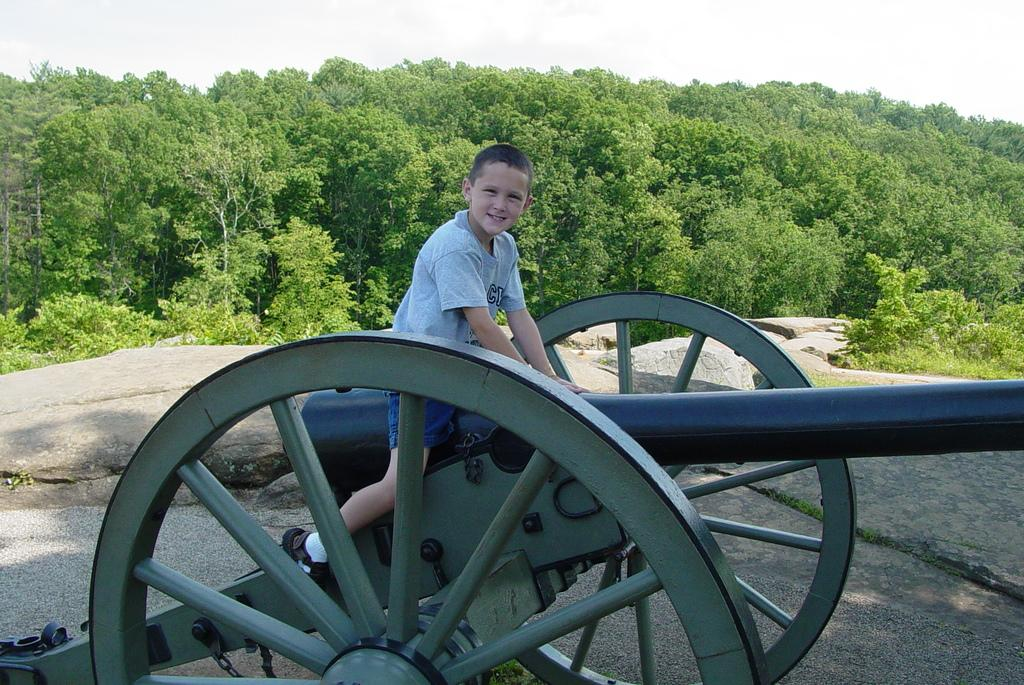Who is the main subject in the image? There is a boy in the image. What is the boy doing in the image? The boy is sitting on a cart. Can you describe the cart the boy is sitting on? The cart has wheels. What can be seen in the background of the image? There are trees in the background of the image. What is visible above the trees in the image? The sky is visible in the image. What type of eyes can be seen on the cart in the image? There are no eyes present on the cart in the image. Is there a playground visible in the image? There is no playground visible in the image. 